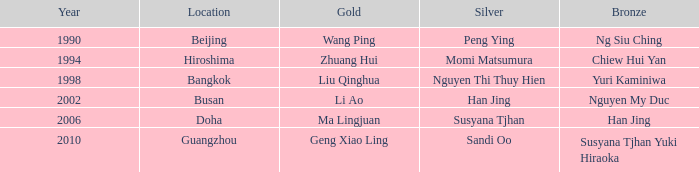What's the bronze associated with the year 1998? Yuri Kaminiwa. 